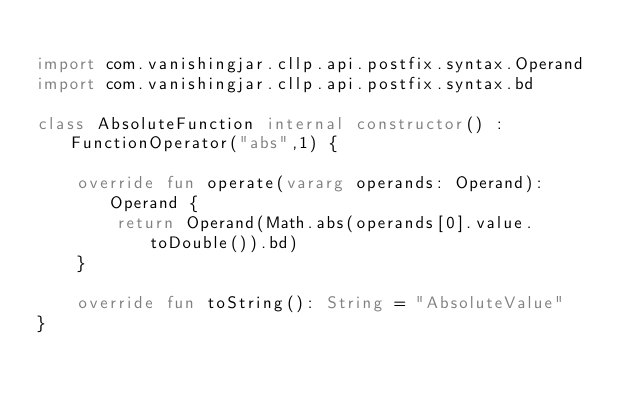Convert code to text. <code><loc_0><loc_0><loc_500><loc_500><_Kotlin_>
import com.vanishingjar.cllp.api.postfix.syntax.Operand
import com.vanishingjar.cllp.api.postfix.syntax.bd

class AbsoluteFunction internal constructor() : FunctionOperator("abs",1) {

    override fun operate(vararg operands: Operand): Operand {
        return Operand(Math.abs(operands[0].value.toDouble()).bd)
    }

    override fun toString(): String = "AbsoluteValue"
}</code> 